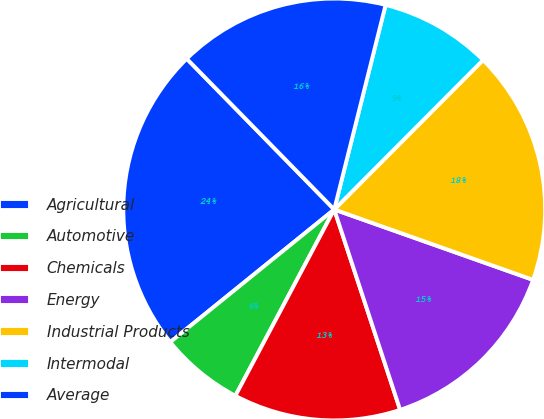Convert chart. <chart><loc_0><loc_0><loc_500><loc_500><pie_chart><fcel>Agricultural<fcel>Automotive<fcel>Chemicals<fcel>Energy<fcel>Industrial Products<fcel>Intermodal<fcel>Average<nl><fcel>23.5%<fcel>6.41%<fcel>12.82%<fcel>14.53%<fcel>17.95%<fcel>8.55%<fcel>16.24%<nl></chart> 